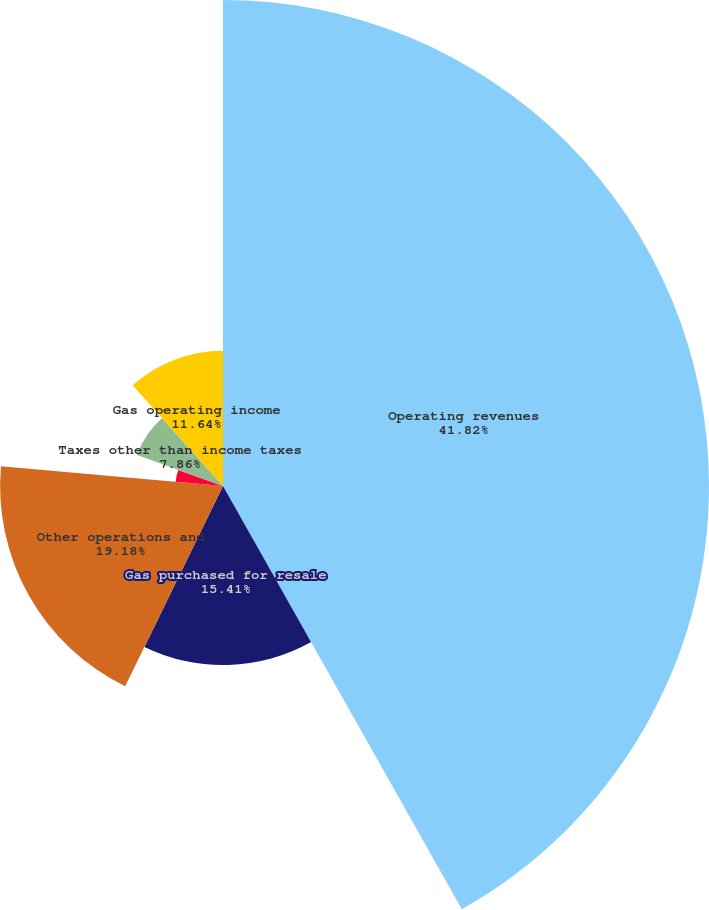<chart> <loc_0><loc_0><loc_500><loc_500><pie_chart><fcel>Operating revenues<fcel>Gas purchased for resale<fcel>Other operations and<fcel>Depreciation and amortization<fcel>Taxes other than income taxes<fcel>Gas operating income<nl><fcel>41.82%<fcel>15.41%<fcel>19.18%<fcel>4.09%<fcel>7.86%<fcel>11.64%<nl></chart> 